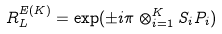Convert formula to latex. <formula><loc_0><loc_0><loc_500><loc_500>R _ { L } ^ { E ( K ) } = \exp ( \pm i \pi \otimes _ { i = 1 } ^ { K } S _ { i } P _ { i } )</formula> 